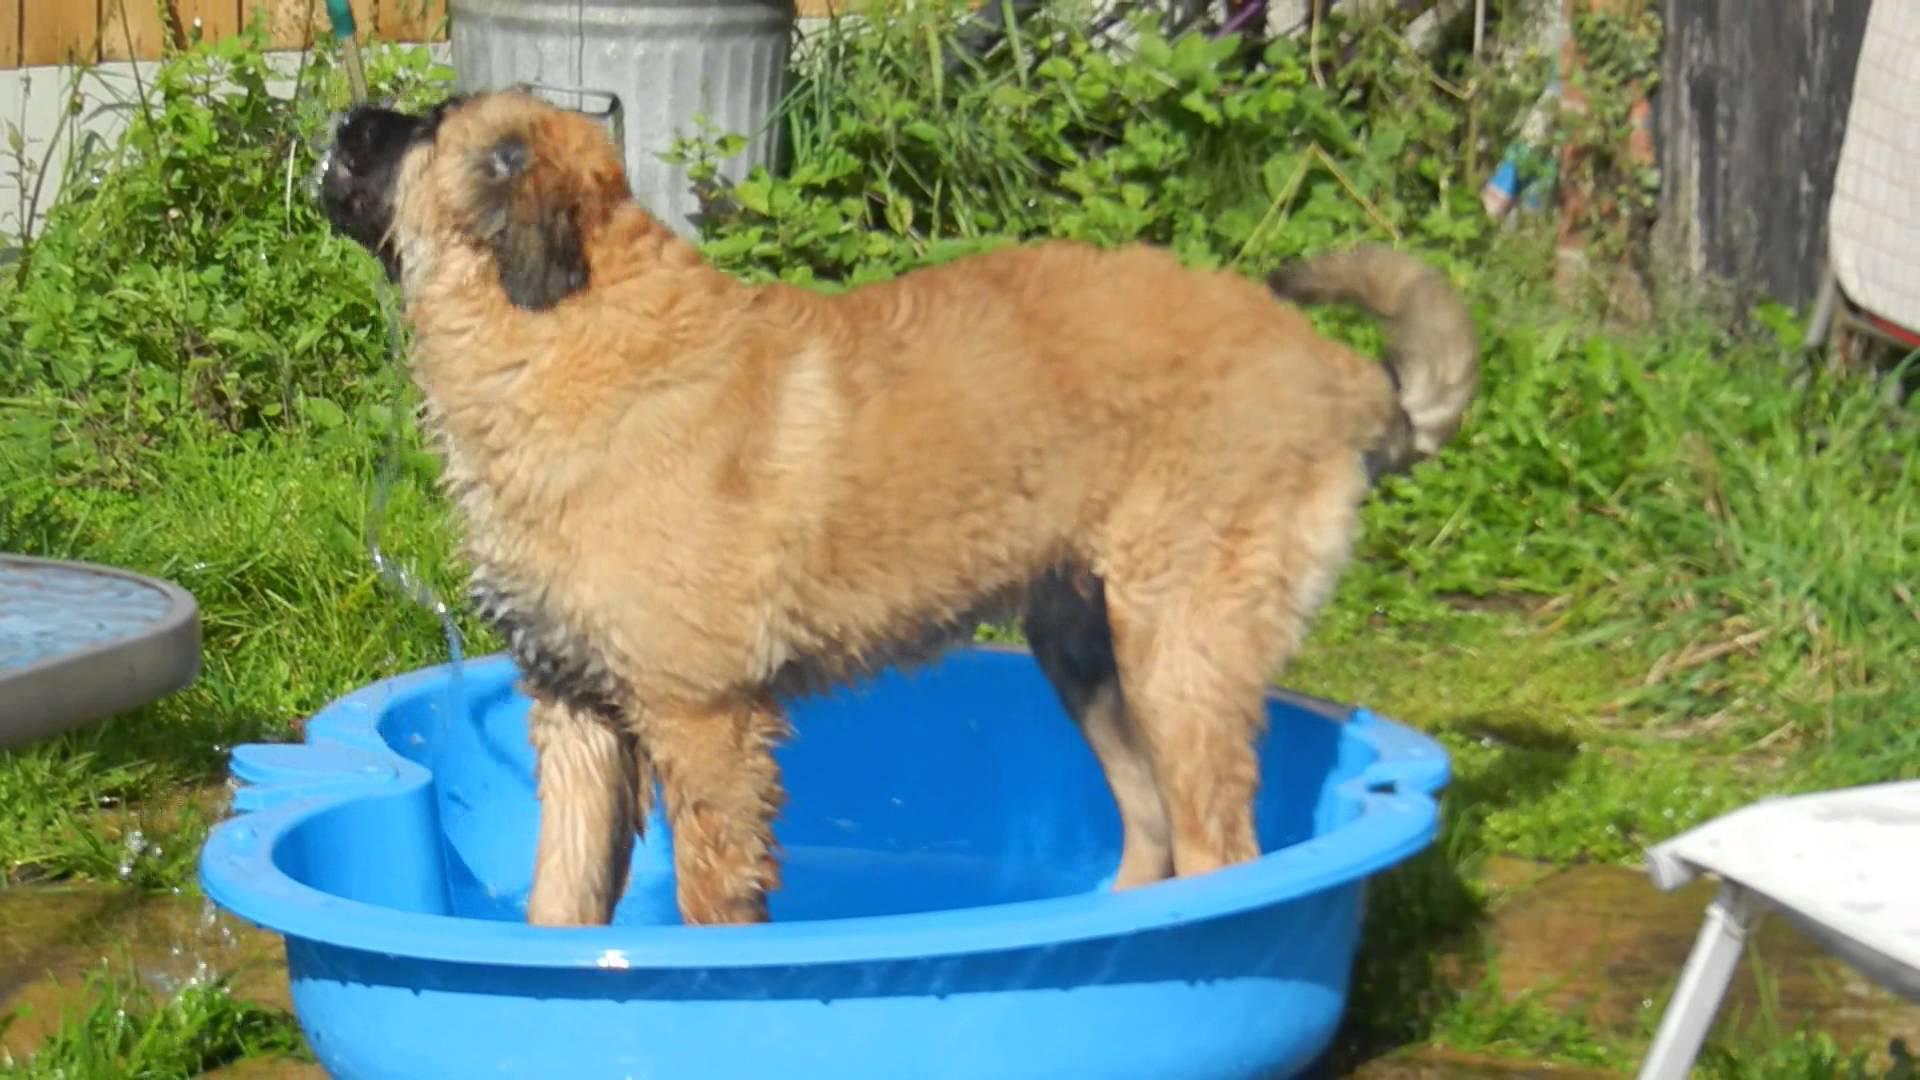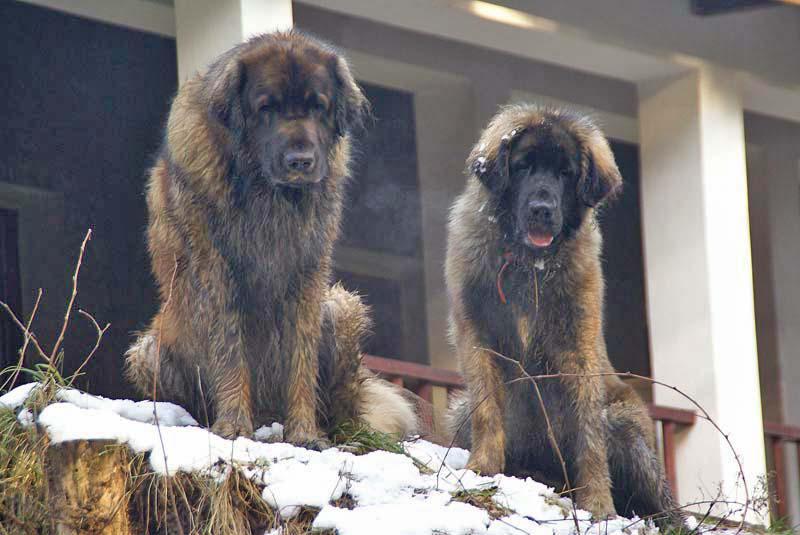The first image is the image on the left, the second image is the image on the right. Examine the images to the left and right. Is the description "A blue plastic plaything of some type is on the grass in one of the images featuring a big brownish-orange dog." accurate? Answer yes or no. Yes. The first image is the image on the left, the second image is the image on the right. Examine the images to the left and right. Is the description "There are three dogs in the pair of images." accurate? Answer yes or no. Yes. 